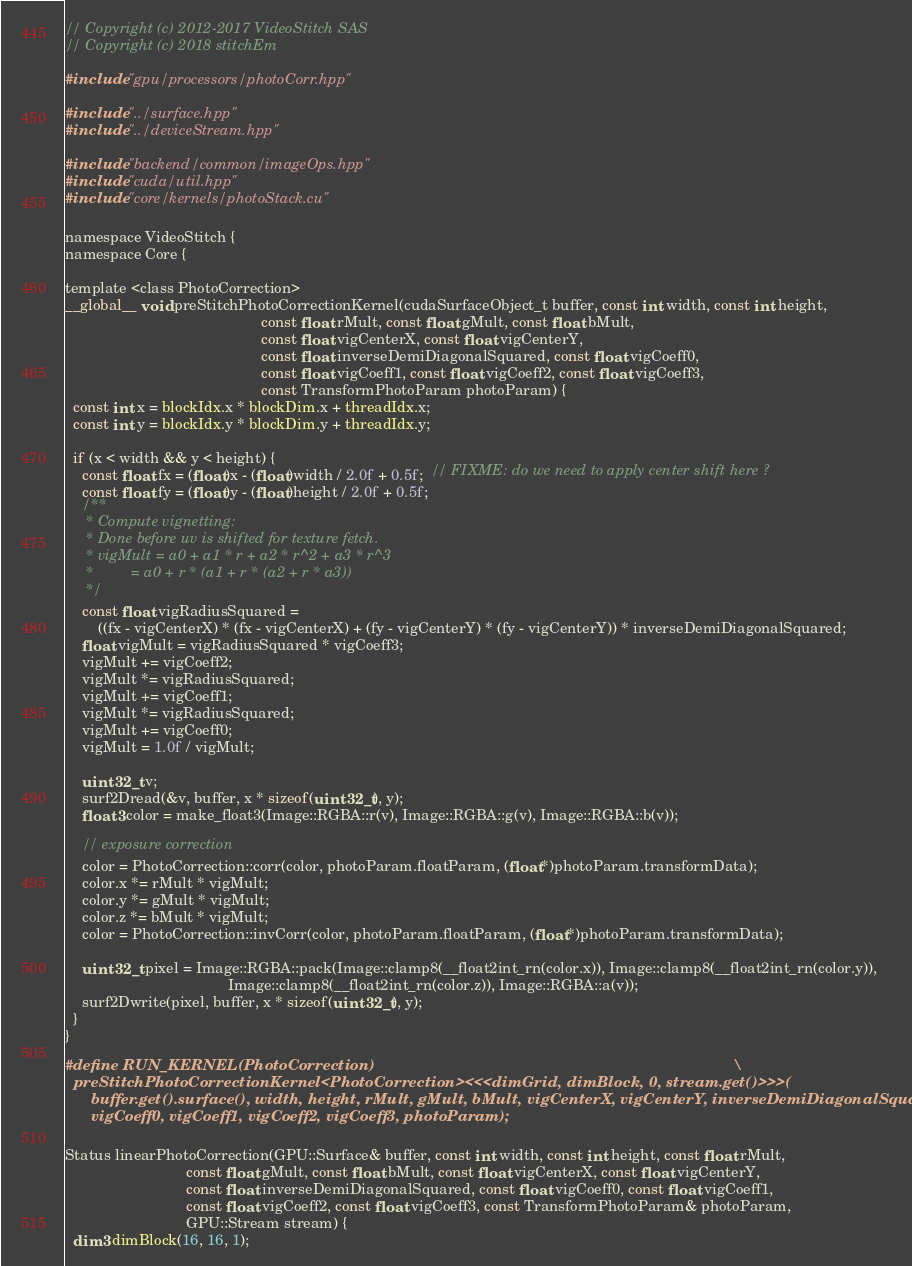<code> <loc_0><loc_0><loc_500><loc_500><_Cuda_>// Copyright (c) 2012-2017 VideoStitch SAS
// Copyright (c) 2018 stitchEm

#include "gpu/processors/photoCorr.hpp"

#include "../surface.hpp"
#include "../deviceStream.hpp"

#include "backend/common/imageOps.hpp"
#include "cuda/util.hpp"
#include "core/kernels/photoStack.cu"

namespace VideoStitch {
namespace Core {

template <class PhotoCorrection>
__global__ void preStitchPhotoCorrectionKernel(cudaSurfaceObject_t buffer, const int width, const int height,
                                               const float rMult, const float gMult, const float bMult,
                                               const float vigCenterX, const float vigCenterY,
                                               const float inverseDemiDiagonalSquared, const float vigCoeff0,
                                               const float vigCoeff1, const float vigCoeff2, const float vigCoeff3,
                                               const TransformPhotoParam photoParam) {
  const int x = blockIdx.x * blockDim.x + threadIdx.x;
  const int y = blockIdx.y * blockDim.y + threadIdx.y;

  if (x < width && y < height) {
    const float fx = (float)x - (float)width / 2.0f + 0.5f;  // FIXME: do we need to apply center shift here ?
    const float fy = (float)y - (float)height / 2.0f + 0.5f;
    /**
     * Compute vignetting:
     * Done before uv is shifted for texture fetch.
     * vigMult = a0 + a1 * r + a2 * r^2 + a3 * r^3
     *         = a0 + r * (a1 + r * (a2 + r * a3))
     */
    const float vigRadiusSquared =
        ((fx - vigCenterX) * (fx - vigCenterX) + (fy - vigCenterY) * (fy - vigCenterY)) * inverseDemiDiagonalSquared;
    float vigMult = vigRadiusSquared * vigCoeff3;
    vigMult += vigCoeff2;
    vigMult *= vigRadiusSquared;
    vigMult += vigCoeff1;
    vigMult *= vigRadiusSquared;
    vigMult += vigCoeff0;
    vigMult = 1.0f / vigMult;

    uint32_t v;
    surf2Dread(&v, buffer, x * sizeof(uint32_t), y);
    float3 color = make_float3(Image::RGBA::r(v), Image::RGBA::g(v), Image::RGBA::b(v));

    // exposure correction
    color = PhotoCorrection::corr(color, photoParam.floatParam, (float*)photoParam.transformData);
    color.x *= rMult * vigMult;
    color.y *= gMult * vigMult;
    color.z *= bMult * vigMult;
    color = PhotoCorrection::invCorr(color, photoParam.floatParam, (float*)photoParam.transformData);

    uint32_t pixel = Image::RGBA::pack(Image::clamp8(__float2int_rn(color.x)), Image::clamp8(__float2int_rn(color.y)),
                                       Image::clamp8(__float2int_rn(color.z)), Image::RGBA::a(v));
    surf2Dwrite(pixel, buffer, x * sizeof(uint32_t), y);
  }
}

#define RUN_KERNEL(PhotoCorrection)                                                                                   \
  preStitchPhotoCorrectionKernel<PhotoCorrection><<<dimGrid, dimBlock, 0, stream.get()>>>(                            \
      buffer.get().surface(), width, height, rMult, gMult, bMult, vigCenterX, vigCenterY, inverseDemiDiagonalSquared, \
      vigCoeff0, vigCoeff1, vigCoeff2, vigCoeff3, photoParam);

Status linearPhotoCorrection(GPU::Surface& buffer, const int width, const int height, const float rMult,
                             const float gMult, const float bMult, const float vigCenterX, const float vigCenterY,
                             const float inverseDemiDiagonalSquared, const float vigCoeff0, const float vigCoeff1,
                             const float vigCoeff2, const float vigCoeff3, const TransformPhotoParam& photoParam,
                             GPU::Stream stream) {
  dim3 dimBlock(16, 16, 1);</code> 